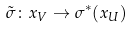<formula> <loc_0><loc_0><loc_500><loc_500>\tilde { \sigma } \colon x _ { V } \to \sigma ^ { * } ( x _ { U } )</formula> 